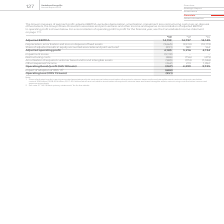According to Vodafone Group Plc's financial document, How much is the excluded depreciation and amortisation for 2019 adjusted EBITDA? According to the financial document, (9,665) (in millions). The relevant text states: "amortisation and loss on disposal of fixed assets (9,665) (9,910) (10,179) Share of adjusted results in equity accounted associates and joint ventures 1 (291)..." Also, How much is the excluded depreciation and amortisation for 2018 adjusted EBITDA? According to the financial document, (9,910) (in millions). The relevant text states: "ation and loss on disposal of fixed assets (9,665) (9,910) (10,179) Share of adjusted results in equity accounted associates and joint ventures 1 (291) 389 164..." Also, How much is the 2019 adjusted EBITDA? According to the financial document, 14,139 (in millions). The relevant text states: "2019 2018 2017 €m €m €m Adjusted EBITDA 14,139 14,737 14,149 Depreciation, amortisation and loss on disposal of fixed assets (9,665) (9,910) (10,1..." Also, can you calculate: How much is the average adjusted EBITDA between 2018 and 2019? To answer this question, I need to perform calculations using the financial data. The calculation is: (14,139+14,737)/2, which equals 14438 (in millions). This is based on the information: "2019 2018 2017 €m €m €m Adjusted EBITDA 14,139 14,737 14,149 Depreciation, amortisation and loss on disposal of fixed assets (9,665) (9,910) (10,179) Sha 2019 2018 2017 €m €m €m Adjusted EBITDA 14,139..." The key data points involved are: 14,139, 14,737. Also, can you calculate: How much is the average adjusted EBITDA between 2018 and 2017? To answer this question, I need to perform calculations using the financial data. The calculation is: (14,737+14,149)/2, which equals 14443 (in millions). This is based on the information: "2018 2017 €m €m €m Adjusted EBITDA 14,139 14,737 14,149 Depreciation, amortisation and loss on disposal of fixed assets (9,665) (9,910) (10,179) Share of a 2019 2018 2017 €m €m €m Adjusted EBITDA 14,1..." The key data points involved are: 14,149, 14,737. Also, can you calculate: What is the change in average adjusted EBITDA between 2018 and 2019, and 2017 and 2018? To answer this question, I need to perform calculations using the financial data. The calculation is: [(14,139+14,737)/2] - [(14,737+14,149)/2], which equals -5 (in millions). This is based on the information: "2019 2018 2017 €m €m €m Adjusted EBITDA 14,139 14,737 14,149 Depreciation, amortisation and loss on disposal of fixed assets (9,665) (9,910) (10,1 2018 2017 €m €m €m Adjusted EBITDA 14,139 14,737 14,1..." The key data points involved are: 14,139, 14,149, 14,737. 